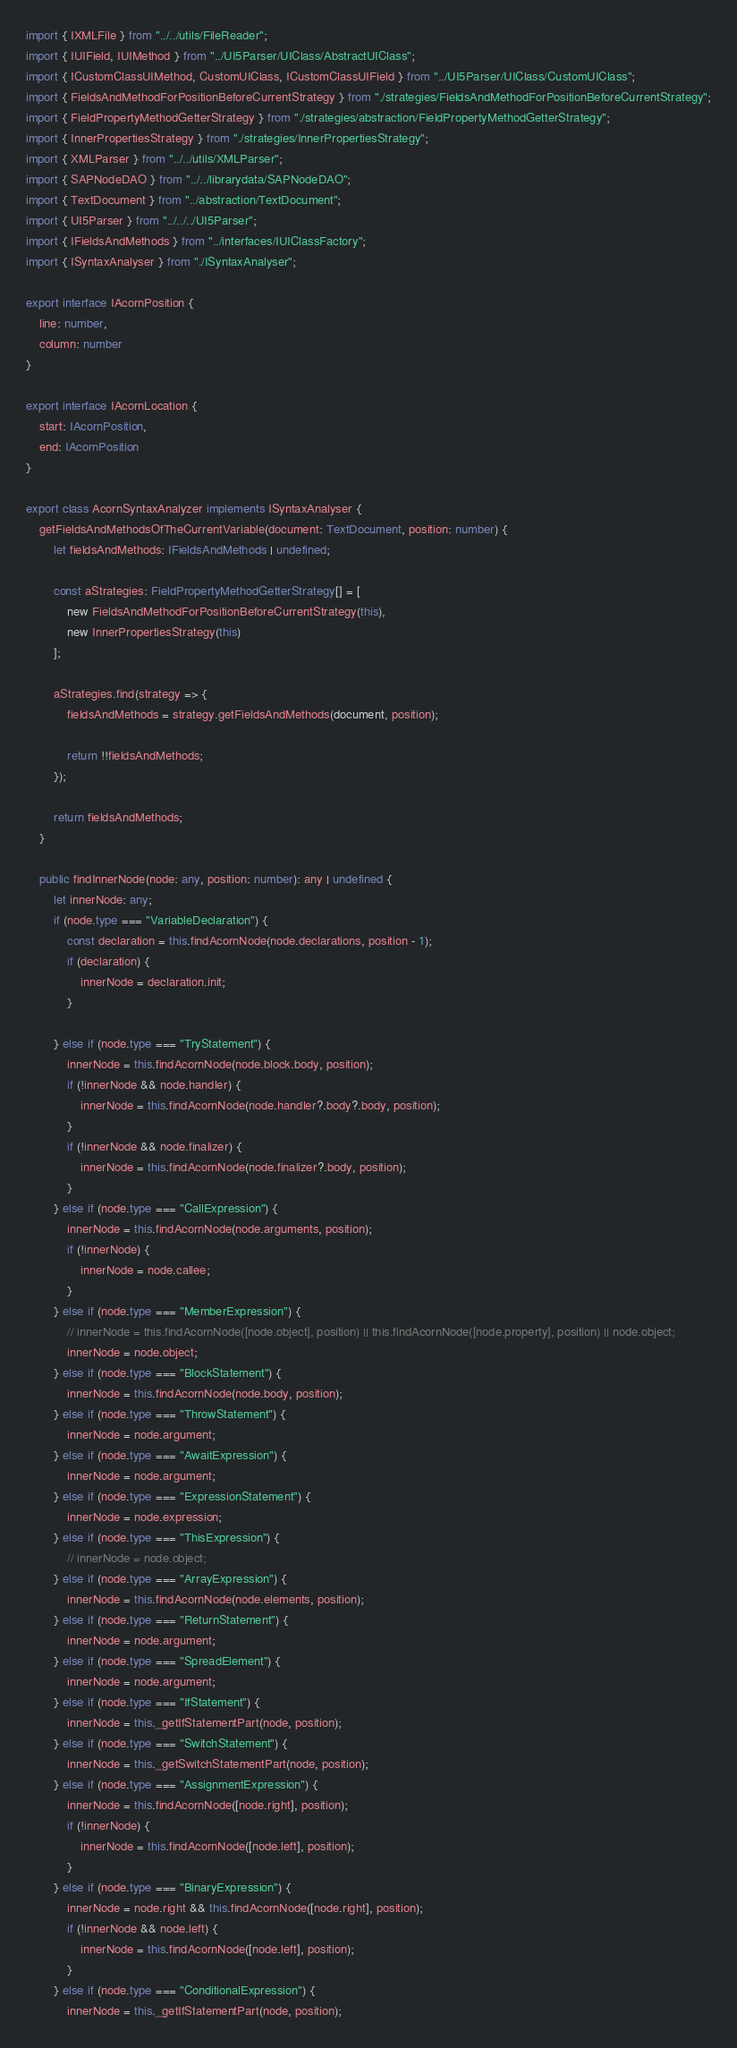Convert code to text. <code><loc_0><loc_0><loc_500><loc_500><_TypeScript_>import { IXMLFile } from "../../utils/FileReader";
import { IUIField, IUIMethod } from "../UI5Parser/UIClass/AbstractUIClass";
import { ICustomClassUIMethod, CustomUIClass, ICustomClassUIField } from "../UI5Parser/UIClass/CustomUIClass";
import { FieldsAndMethodForPositionBeforeCurrentStrategy } from "./strategies/FieldsAndMethodForPositionBeforeCurrentStrategy";
import { FieldPropertyMethodGetterStrategy } from "./strategies/abstraction/FieldPropertyMethodGetterStrategy";
import { InnerPropertiesStrategy } from "./strategies/InnerPropertiesStrategy";
import { XMLParser } from "../../utils/XMLParser";
import { SAPNodeDAO } from "../../librarydata/SAPNodeDAO";
import { TextDocument } from "../abstraction/TextDocument";
import { UI5Parser } from "../../../UI5Parser";
import { IFieldsAndMethods } from "../interfaces/IUIClassFactory";
import { ISyntaxAnalyser } from "./ISyntaxAnalyser";

export interface IAcornPosition {
	line: number,
	column: number
}

export interface IAcornLocation {
	start: IAcornPosition,
	end: IAcornPosition
}

export class AcornSyntaxAnalyzer implements ISyntaxAnalyser {
	getFieldsAndMethodsOfTheCurrentVariable(document: TextDocument, position: number) {
		let fieldsAndMethods: IFieldsAndMethods | undefined;

		const aStrategies: FieldPropertyMethodGetterStrategy[] = [
			new FieldsAndMethodForPositionBeforeCurrentStrategy(this),
			new InnerPropertiesStrategy(this)
		];

		aStrategies.find(strategy => {
			fieldsAndMethods = strategy.getFieldsAndMethods(document, position);

			return !!fieldsAndMethods;
		});

		return fieldsAndMethods;
	}

	public findInnerNode(node: any, position: number): any | undefined {
		let innerNode: any;
		if (node.type === "VariableDeclaration") {
			const declaration = this.findAcornNode(node.declarations, position - 1);
			if (declaration) {
				innerNode = declaration.init;
			}

		} else if (node.type === "TryStatement") {
			innerNode = this.findAcornNode(node.block.body, position);
			if (!innerNode && node.handler) {
				innerNode = this.findAcornNode(node.handler?.body?.body, position);
			}
			if (!innerNode && node.finalizer) {
				innerNode = this.findAcornNode(node.finalizer?.body, position);
			}
		} else if (node.type === "CallExpression") {
			innerNode = this.findAcornNode(node.arguments, position);
			if (!innerNode) {
				innerNode = node.callee;
			}
		} else if (node.type === "MemberExpression") {
			// innerNode = this.findAcornNode([node.object], position) || this.findAcornNode([node.property], position) || node.object;
			innerNode = node.object;
		} else if (node.type === "BlockStatement") {
			innerNode = this.findAcornNode(node.body, position);
		} else if (node.type === "ThrowStatement") {
			innerNode = node.argument;
		} else if (node.type === "AwaitExpression") {
			innerNode = node.argument;
		} else if (node.type === "ExpressionStatement") {
			innerNode = node.expression;
		} else if (node.type === "ThisExpression") {
			// innerNode = node.object;
		} else if (node.type === "ArrayExpression") {
			innerNode = this.findAcornNode(node.elements, position);
		} else if (node.type === "ReturnStatement") {
			innerNode = node.argument;
		} else if (node.type === "SpreadElement") {
			innerNode = node.argument;
		} else if (node.type === "IfStatement") {
			innerNode = this._getIfStatementPart(node, position);
		} else if (node.type === "SwitchStatement") {
			innerNode = this._getSwitchStatementPart(node, position);
		} else if (node.type === "AssignmentExpression") {
			innerNode = this.findAcornNode([node.right], position);
			if (!innerNode) {
				innerNode = this.findAcornNode([node.left], position);
			}
		} else if (node.type === "BinaryExpression") {
			innerNode = node.right && this.findAcornNode([node.right], position);
			if (!innerNode && node.left) {
				innerNode = this.findAcornNode([node.left], position);
			}
		} else if (node.type === "ConditionalExpression") {
			innerNode = this._getIfStatementPart(node, position);</code> 